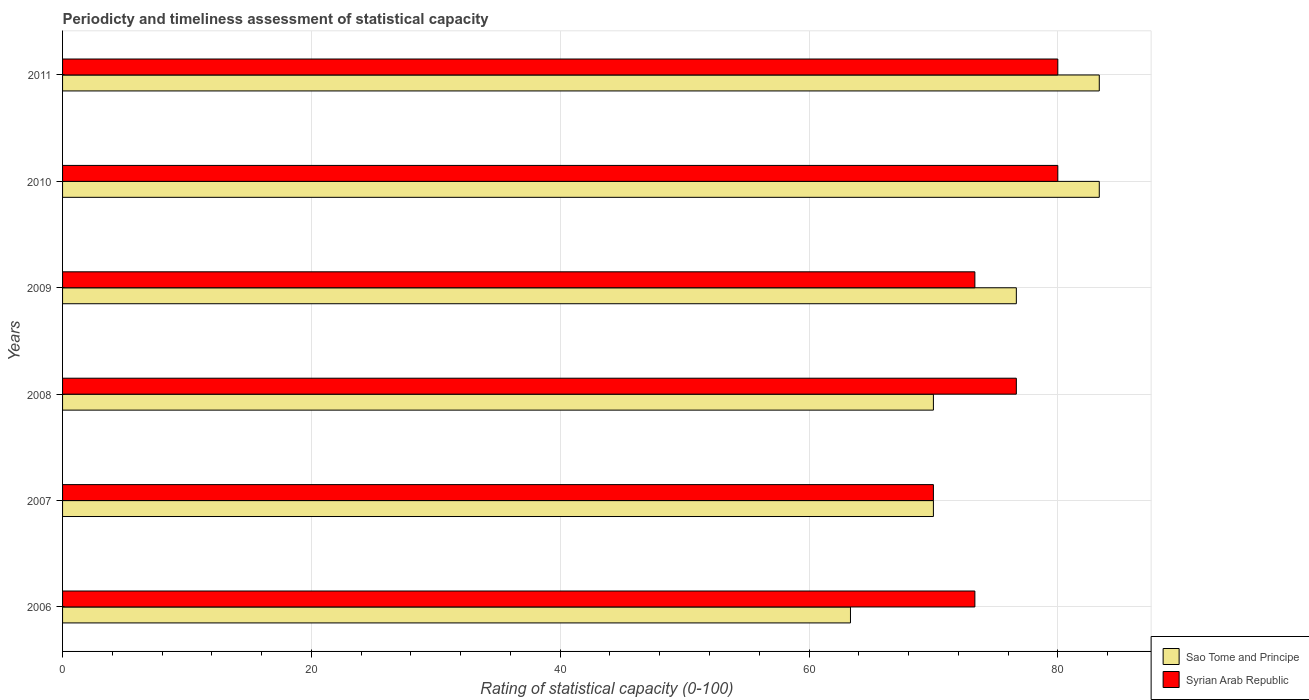Are the number of bars per tick equal to the number of legend labels?
Your response must be concise. Yes. Are the number of bars on each tick of the Y-axis equal?
Offer a terse response. Yes. How many bars are there on the 2nd tick from the top?
Ensure brevity in your answer.  2. What is the label of the 6th group of bars from the top?
Keep it short and to the point. 2006. What is the rating of statistical capacity in Sao Tome and Principe in 2006?
Provide a succinct answer. 63.33. Across all years, what is the maximum rating of statistical capacity in Sao Tome and Principe?
Keep it short and to the point. 83.33. Across all years, what is the minimum rating of statistical capacity in Syrian Arab Republic?
Your answer should be very brief. 70. In which year was the rating of statistical capacity in Syrian Arab Republic maximum?
Your answer should be compact. 2010. What is the total rating of statistical capacity in Sao Tome and Principe in the graph?
Give a very brief answer. 446.67. What is the difference between the rating of statistical capacity in Syrian Arab Republic in 2008 and that in 2010?
Your answer should be very brief. -3.33. What is the difference between the rating of statistical capacity in Syrian Arab Republic in 2009 and the rating of statistical capacity in Sao Tome and Principe in 2008?
Offer a very short reply. 3.33. What is the average rating of statistical capacity in Syrian Arab Republic per year?
Make the answer very short. 75.56. In the year 2010, what is the difference between the rating of statistical capacity in Syrian Arab Republic and rating of statistical capacity in Sao Tome and Principe?
Make the answer very short. -3.33. What is the ratio of the rating of statistical capacity in Syrian Arab Republic in 2007 to that in 2008?
Your answer should be compact. 0.91. Is the difference between the rating of statistical capacity in Syrian Arab Republic in 2007 and 2011 greater than the difference between the rating of statistical capacity in Sao Tome and Principe in 2007 and 2011?
Your answer should be compact. Yes. What is the difference between the highest and the second highest rating of statistical capacity in Sao Tome and Principe?
Ensure brevity in your answer.  0. What is the difference between the highest and the lowest rating of statistical capacity in Sao Tome and Principe?
Your response must be concise. 20. In how many years, is the rating of statistical capacity in Syrian Arab Republic greater than the average rating of statistical capacity in Syrian Arab Republic taken over all years?
Offer a terse response. 3. Is the sum of the rating of statistical capacity in Sao Tome and Principe in 2009 and 2011 greater than the maximum rating of statistical capacity in Syrian Arab Republic across all years?
Keep it short and to the point. Yes. What does the 2nd bar from the top in 2007 represents?
Your answer should be compact. Sao Tome and Principe. What does the 1st bar from the bottom in 2008 represents?
Your answer should be very brief. Sao Tome and Principe. Are all the bars in the graph horizontal?
Ensure brevity in your answer.  Yes. How are the legend labels stacked?
Your answer should be compact. Vertical. What is the title of the graph?
Give a very brief answer. Periodicty and timeliness assessment of statistical capacity. What is the label or title of the X-axis?
Give a very brief answer. Rating of statistical capacity (0-100). What is the label or title of the Y-axis?
Ensure brevity in your answer.  Years. What is the Rating of statistical capacity (0-100) in Sao Tome and Principe in 2006?
Give a very brief answer. 63.33. What is the Rating of statistical capacity (0-100) of Syrian Arab Republic in 2006?
Make the answer very short. 73.33. What is the Rating of statistical capacity (0-100) in Sao Tome and Principe in 2007?
Offer a very short reply. 70. What is the Rating of statistical capacity (0-100) in Sao Tome and Principe in 2008?
Your response must be concise. 70. What is the Rating of statistical capacity (0-100) of Syrian Arab Republic in 2008?
Offer a very short reply. 76.67. What is the Rating of statistical capacity (0-100) in Sao Tome and Principe in 2009?
Offer a terse response. 76.67. What is the Rating of statistical capacity (0-100) of Syrian Arab Republic in 2009?
Offer a very short reply. 73.33. What is the Rating of statistical capacity (0-100) in Sao Tome and Principe in 2010?
Provide a short and direct response. 83.33. What is the Rating of statistical capacity (0-100) in Syrian Arab Republic in 2010?
Offer a very short reply. 80. What is the Rating of statistical capacity (0-100) of Sao Tome and Principe in 2011?
Give a very brief answer. 83.33. Across all years, what is the maximum Rating of statistical capacity (0-100) of Sao Tome and Principe?
Offer a terse response. 83.33. Across all years, what is the minimum Rating of statistical capacity (0-100) of Sao Tome and Principe?
Ensure brevity in your answer.  63.33. Across all years, what is the minimum Rating of statistical capacity (0-100) of Syrian Arab Republic?
Offer a very short reply. 70. What is the total Rating of statistical capacity (0-100) in Sao Tome and Principe in the graph?
Ensure brevity in your answer.  446.67. What is the total Rating of statistical capacity (0-100) in Syrian Arab Republic in the graph?
Provide a short and direct response. 453.33. What is the difference between the Rating of statistical capacity (0-100) of Sao Tome and Principe in 2006 and that in 2007?
Ensure brevity in your answer.  -6.67. What is the difference between the Rating of statistical capacity (0-100) in Sao Tome and Principe in 2006 and that in 2008?
Offer a terse response. -6.67. What is the difference between the Rating of statistical capacity (0-100) in Sao Tome and Principe in 2006 and that in 2009?
Provide a short and direct response. -13.33. What is the difference between the Rating of statistical capacity (0-100) of Syrian Arab Republic in 2006 and that in 2009?
Your response must be concise. 0. What is the difference between the Rating of statistical capacity (0-100) in Syrian Arab Republic in 2006 and that in 2010?
Your answer should be very brief. -6.67. What is the difference between the Rating of statistical capacity (0-100) of Sao Tome and Principe in 2006 and that in 2011?
Provide a succinct answer. -20. What is the difference between the Rating of statistical capacity (0-100) in Syrian Arab Republic in 2006 and that in 2011?
Ensure brevity in your answer.  -6.67. What is the difference between the Rating of statistical capacity (0-100) in Sao Tome and Principe in 2007 and that in 2008?
Your answer should be very brief. 0. What is the difference between the Rating of statistical capacity (0-100) of Syrian Arab Republic in 2007 and that in 2008?
Offer a terse response. -6.67. What is the difference between the Rating of statistical capacity (0-100) in Sao Tome and Principe in 2007 and that in 2009?
Your answer should be very brief. -6.67. What is the difference between the Rating of statistical capacity (0-100) in Syrian Arab Republic in 2007 and that in 2009?
Your response must be concise. -3.33. What is the difference between the Rating of statistical capacity (0-100) of Sao Tome and Principe in 2007 and that in 2010?
Your answer should be very brief. -13.33. What is the difference between the Rating of statistical capacity (0-100) in Syrian Arab Republic in 2007 and that in 2010?
Keep it short and to the point. -10. What is the difference between the Rating of statistical capacity (0-100) in Sao Tome and Principe in 2007 and that in 2011?
Your answer should be very brief. -13.33. What is the difference between the Rating of statistical capacity (0-100) of Sao Tome and Principe in 2008 and that in 2009?
Make the answer very short. -6.67. What is the difference between the Rating of statistical capacity (0-100) in Syrian Arab Republic in 2008 and that in 2009?
Your answer should be compact. 3.33. What is the difference between the Rating of statistical capacity (0-100) in Sao Tome and Principe in 2008 and that in 2010?
Your answer should be compact. -13.33. What is the difference between the Rating of statistical capacity (0-100) in Syrian Arab Republic in 2008 and that in 2010?
Provide a short and direct response. -3.33. What is the difference between the Rating of statistical capacity (0-100) of Sao Tome and Principe in 2008 and that in 2011?
Offer a very short reply. -13.33. What is the difference between the Rating of statistical capacity (0-100) in Syrian Arab Republic in 2008 and that in 2011?
Make the answer very short. -3.33. What is the difference between the Rating of statistical capacity (0-100) of Sao Tome and Principe in 2009 and that in 2010?
Keep it short and to the point. -6.67. What is the difference between the Rating of statistical capacity (0-100) in Syrian Arab Republic in 2009 and that in 2010?
Offer a very short reply. -6.67. What is the difference between the Rating of statistical capacity (0-100) in Sao Tome and Principe in 2009 and that in 2011?
Ensure brevity in your answer.  -6.67. What is the difference between the Rating of statistical capacity (0-100) in Syrian Arab Republic in 2009 and that in 2011?
Provide a short and direct response. -6.67. What is the difference between the Rating of statistical capacity (0-100) of Sao Tome and Principe in 2010 and that in 2011?
Make the answer very short. 0. What is the difference between the Rating of statistical capacity (0-100) in Syrian Arab Republic in 2010 and that in 2011?
Your answer should be compact. 0. What is the difference between the Rating of statistical capacity (0-100) of Sao Tome and Principe in 2006 and the Rating of statistical capacity (0-100) of Syrian Arab Republic in 2007?
Provide a succinct answer. -6.67. What is the difference between the Rating of statistical capacity (0-100) of Sao Tome and Principe in 2006 and the Rating of statistical capacity (0-100) of Syrian Arab Republic in 2008?
Your answer should be compact. -13.33. What is the difference between the Rating of statistical capacity (0-100) in Sao Tome and Principe in 2006 and the Rating of statistical capacity (0-100) in Syrian Arab Republic in 2009?
Your response must be concise. -10. What is the difference between the Rating of statistical capacity (0-100) of Sao Tome and Principe in 2006 and the Rating of statistical capacity (0-100) of Syrian Arab Republic in 2010?
Ensure brevity in your answer.  -16.67. What is the difference between the Rating of statistical capacity (0-100) in Sao Tome and Principe in 2006 and the Rating of statistical capacity (0-100) in Syrian Arab Republic in 2011?
Offer a terse response. -16.67. What is the difference between the Rating of statistical capacity (0-100) of Sao Tome and Principe in 2007 and the Rating of statistical capacity (0-100) of Syrian Arab Republic in 2008?
Provide a succinct answer. -6.67. What is the difference between the Rating of statistical capacity (0-100) of Sao Tome and Principe in 2007 and the Rating of statistical capacity (0-100) of Syrian Arab Republic in 2011?
Keep it short and to the point. -10. What is the difference between the Rating of statistical capacity (0-100) of Sao Tome and Principe in 2008 and the Rating of statistical capacity (0-100) of Syrian Arab Republic in 2010?
Your answer should be compact. -10. What is the difference between the Rating of statistical capacity (0-100) of Sao Tome and Principe in 2008 and the Rating of statistical capacity (0-100) of Syrian Arab Republic in 2011?
Give a very brief answer. -10. What is the difference between the Rating of statistical capacity (0-100) of Sao Tome and Principe in 2009 and the Rating of statistical capacity (0-100) of Syrian Arab Republic in 2011?
Offer a very short reply. -3.33. What is the average Rating of statistical capacity (0-100) in Sao Tome and Principe per year?
Your response must be concise. 74.44. What is the average Rating of statistical capacity (0-100) in Syrian Arab Republic per year?
Provide a short and direct response. 75.56. In the year 2007, what is the difference between the Rating of statistical capacity (0-100) of Sao Tome and Principe and Rating of statistical capacity (0-100) of Syrian Arab Republic?
Provide a succinct answer. 0. In the year 2008, what is the difference between the Rating of statistical capacity (0-100) of Sao Tome and Principe and Rating of statistical capacity (0-100) of Syrian Arab Republic?
Provide a succinct answer. -6.67. In the year 2011, what is the difference between the Rating of statistical capacity (0-100) of Sao Tome and Principe and Rating of statistical capacity (0-100) of Syrian Arab Republic?
Offer a very short reply. 3.33. What is the ratio of the Rating of statistical capacity (0-100) of Sao Tome and Principe in 2006 to that in 2007?
Make the answer very short. 0.9. What is the ratio of the Rating of statistical capacity (0-100) in Syrian Arab Republic in 2006 to that in 2007?
Offer a very short reply. 1.05. What is the ratio of the Rating of statistical capacity (0-100) in Sao Tome and Principe in 2006 to that in 2008?
Provide a short and direct response. 0.9. What is the ratio of the Rating of statistical capacity (0-100) in Syrian Arab Republic in 2006 to that in 2008?
Offer a terse response. 0.96. What is the ratio of the Rating of statistical capacity (0-100) in Sao Tome and Principe in 2006 to that in 2009?
Your answer should be compact. 0.83. What is the ratio of the Rating of statistical capacity (0-100) in Syrian Arab Republic in 2006 to that in 2009?
Your answer should be compact. 1. What is the ratio of the Rating of statistical capacity (0-100) in Sao Tome and Principe in 2006 to that in 2010?
Your answer should be very brief. 0.76. What is the ratio of the Rating of statistical capacity (0-100) in Syrian Arab Republic in 2006 to that in 2010?
Offer a very short reply. 0.92. What is the ratio of the Rating of statistical capacity (0-100) of Sao Tome and Principe in 2006 to that in 2011?
Ensure brevity in your answer.  0.76. What is the ratio of the Rating of statistical capacity (0-100) of Syrian Arab Republic in 2006 to that in 2011?
Ensure brevity in your answer.  0.92. What is the ratio of the Rating of statistical capacity (0-100) of Syrian Arab Republic in 2007 to that in 2009?
Offer a terse response. 0.95. What is the ratio of the Rating of statistical capacity (0-100) in Sao Tome and Principe in 2007 to that in 2010?
Make the answer very short. 0.84. What is the ratio of the Rating of statistical capacity (0-100) in Syrian Arab Republic in 2007 to that in 2010?
Make the answer very short. 0.88. What is the ratio of the Rating of statistical capacity (0-100) in Sao Tome and Principe in 2007 to that in 2011?
Keep it short and to the point. 0.84. What is the ratio of the Rating of statistical capacity (0-100) in Sao Tome and Principe in 2008 to that in 2009?
Provide a short and direct response. 0.91. What is the ratio of the Rating of statistical capacity (0-100) of Syrian Arab Republic in 2008 to that in 2009?
Keep it short and to the point. 1.05. What is the ratio of the Rating of statistical capacity (0-100) in Sao Tome and Principe in 2008 to that in 2010?
Make the answer very short. 0.84. What is the ratio of the Rating of statistical capacity (0-100) in Syrian Arab Republic in 2008 to that in 2010?
Provide a succinct answer. 0.96. What is the ratio of the Rating of statistical capacity (0-100) in Sao Tome and Principe in 2008 to that in 2011?
Make the answer very short. 0.84. What is the difference between the highest and the second highest Rating of statistical capacity (0-100) of Sao Tome and Principe?
Give a very brief answer. 0. What is the difference between the highest and the lowest Rating of statistical capacity (0-100) in Sao Tome and Principe?
Offer a very short reply. 20. 